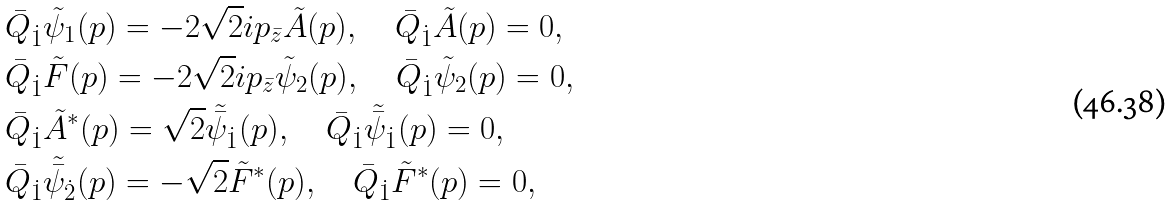Convert formula to latex. <formula><loc_0><loc_0><loc_500><loc_500>& \bar { Q } _ { \dot { 1 } } \tilde { \psi } _ { 1 } ( p ) = - 2 \sqrt { 2 } i p _ { \bar { z } } \tilde { A } ( p ) , \quad \bar { Q } _ { \dot { 1 } } \tilde { A } ( p ) = 0 , \\ & \bar { Q } _ { \dot { 1 } } \tilde { F } ( p ) = - 2 \sqrt { 2 } i p _ { \bar { z } } \tilde { \psi } _ { 2 } ( p ) , \quad \bar { Q } _ { \dot { 1 } } \tilde { \psi } _ { 2 } ( p ) = 0 , \\ & \bar { Q } _ { \dot { 1 } } \tilde { A } ^ { * } ( p ) = \sqrt { 2 } \tilde { \bar { \psi } } _ { \dot { 1 } } ( p ) , \quad \bar { Q } _ { \dot { 1 } } \tilde { \bar { \psi } } _ { \dot { 1 } } ( p ) = 0 , \\ & \bar { Q } _ { \dot { 1 } } \tilde { \bar { \psi } } _ { \dot { 2 } } ( p ) = - \sqrt { 2 } \tilde { F } ^ { * } ( p ) , \quad \bar { Q } _ { \dot { 1 } } \tilde { F } ^ { * } ( p ) = 0 ,</formula> 